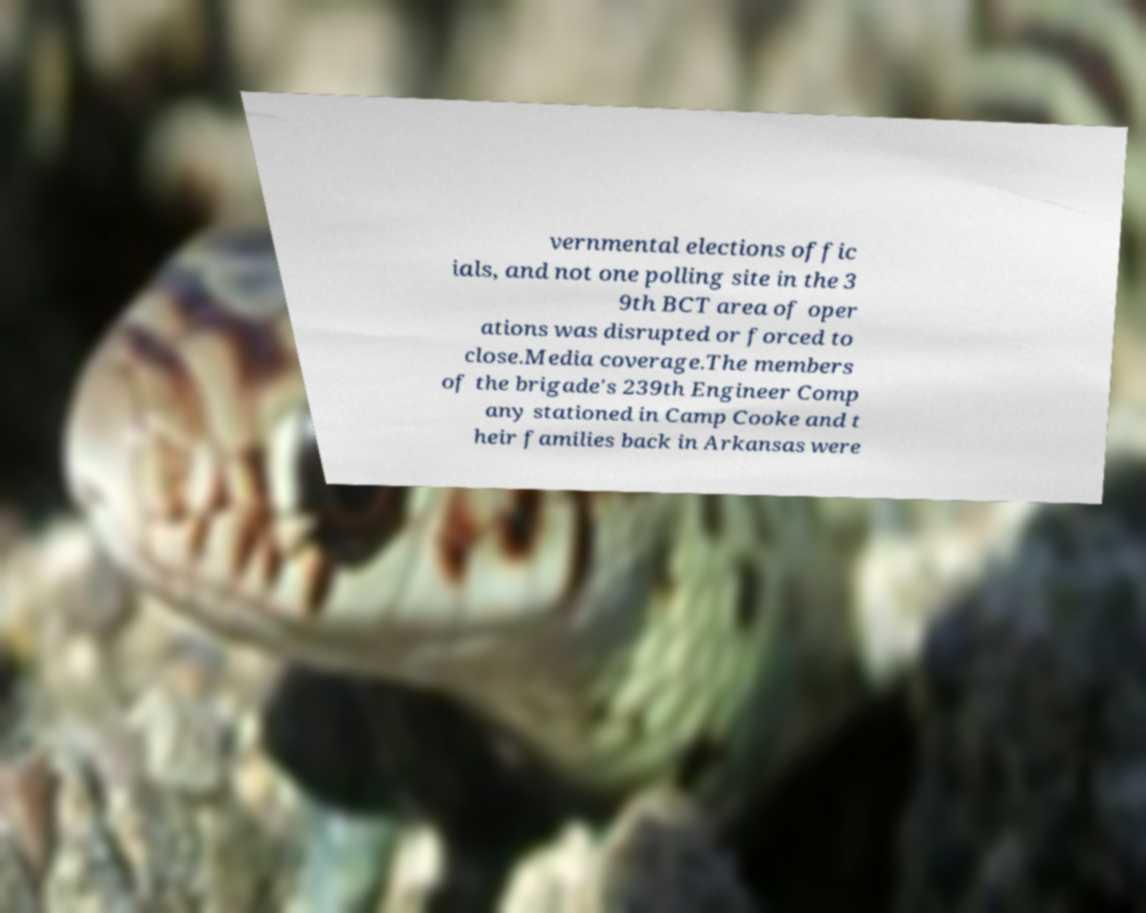What messages or text are displayed in this image? I need them in a readable, typed format. vernmental elections offic ials, and not one polling site in the 3 9th BCT area of oper ations was disrupted or forced to close.Media coverage.The members of the brigade's 239th Engineer Comp any stationed in Camp Cooke and t heir families back in Arkansas were 